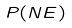Convert formula to latex. <formula><loc_0><loc_0><loc_500><loc_500>P ( N E )</formula> 